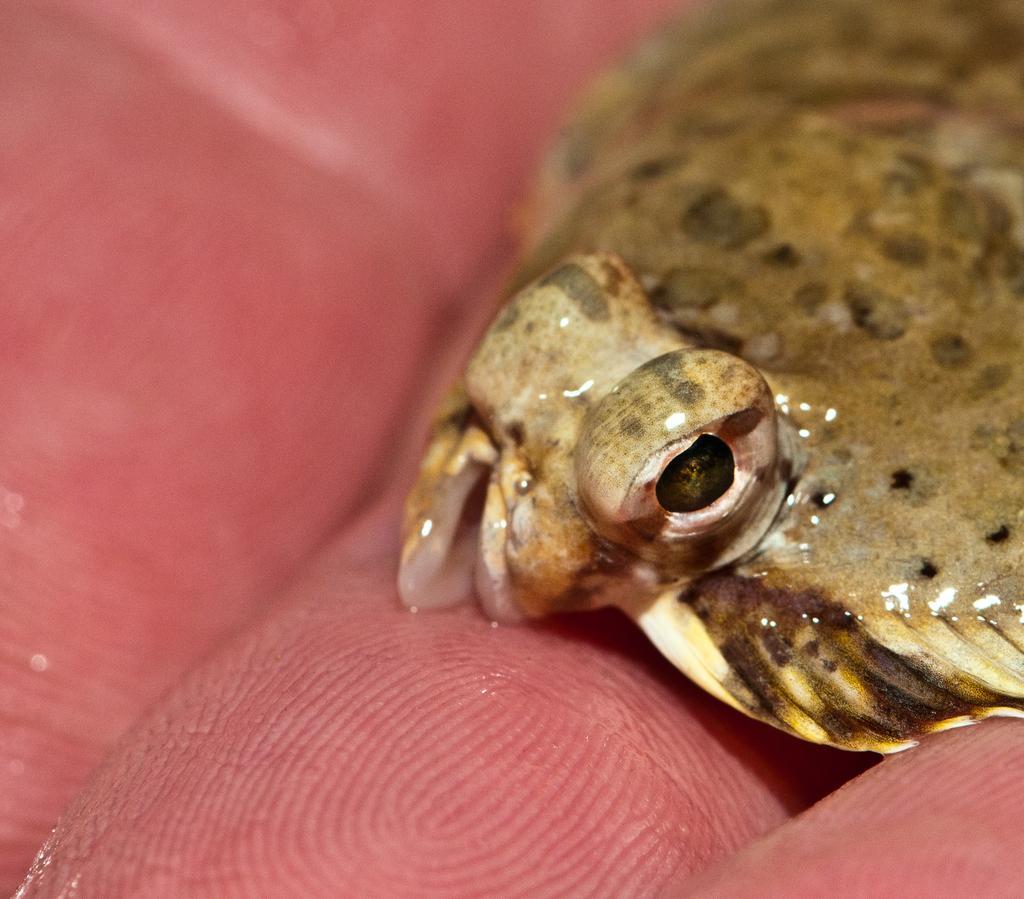In one or two sentences, can you explain what this image depicts? In this image we can see an animal on the fingers of a person. 